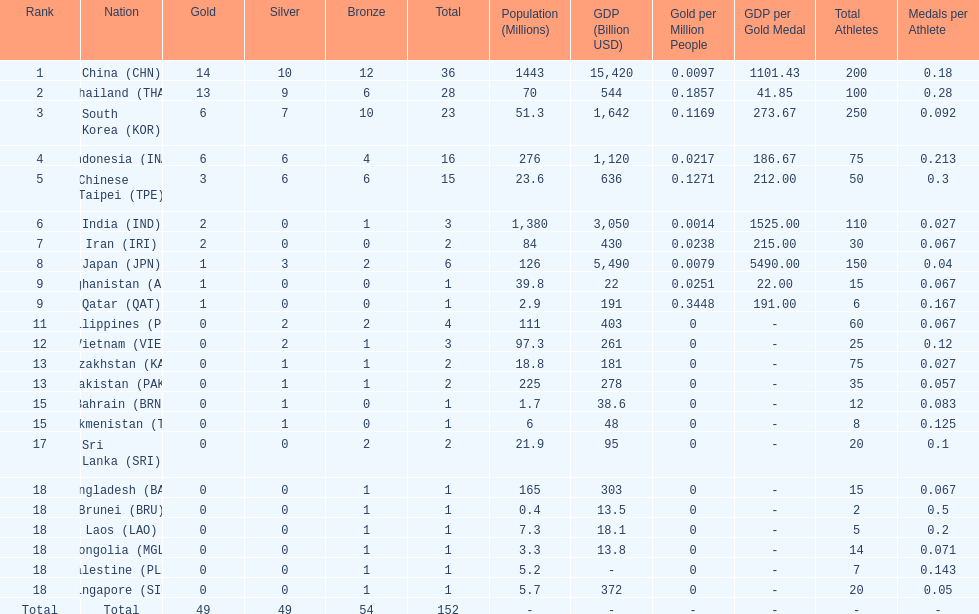How many total gold medal have been given? 49. Can you give me this table as a dict? {'header': ['Rank', 'Nation', 'Gold', 'Silver', 'Bronze', 'Total', 'Population (Millions)', 'GDP (Billion USD)', 'Gold per Million People', 'GDP per Gold Medal', 'Total Athletes', 'Medals per Athlete'], 'rows': [['1', 'China\xa0(CHN)', '14', '10', '12', '36', '1443', '15,420', '0.0097', '1101.43', '200', '0.18'], ['2', 'Thailand\xa0(THA)', '13', '9', '6', '28', '70', '544', '0.1857', '41.85', '100', '0.28'], ['3', 'South Korea\xa0(KOR)', '6', '7', '10', '23', '51.3', '1,642', '0.1169', '273.67', '250', '0.092'], ['4', 'Indonesia\xa0(INA)', '6', '6', '4', '16', '276', '1,120', '0.0217', '186.67', '75', '0.213'], ['5', 'Chinese Taipei\xa0(TPE)', '3', '6', '6', '15', '23.6', '636', '0.1271', '212.00', '50', '0.3'], ['6', 'India\xa0(IND)', '2', '0', '1', '3', '1,380', '3,050', '0.0014', '1525.00', '110', '0.027'], ['7', 'Iran\xa0(IRI)', '2', '0', '0', '2', '84', '430', '0.0238', '215.00', '30', '0.067'], ['8', 'Japan\xa0(JPN)', '1', '3', '2', '6', '126', '5,490', '0.0079', '5490.00', '150', '0.04'], ['9', 'Afghanistan\xa0(AFG)', '1', '0', '0', '1', '39.8', '22', '0.0251', '22.00', '15', '0.067'], ['9', 'Qatar\xa0(QAT)', '1', '0', '0', '1', '2.9', '191', '0.3448', '191.00', '6', '0.167'], ['11', 'Philippines\xa0(PHI)', '0', '2', '2', '4', '111', '403', '0', '-', '60', '0.067'], ['12', 'Vietnam\xa0(VIE)', '0', '2', '1', '3', '97.3', '261', '0', '-', '25', '0.12'], ['13', 'Kazakhstan\xa0(KAZ)', '0', '1', '1', '2', '18.8', '181', '0', '-', '75', '0.027'], ['13', 'Pakistan\xa0(PAK)', '0', '1', '1', '2', '225', '278', '0', '-', '35', '0.057'], ['15', 'Bahrain\xa0(BRN)', '0', '1', '0', '1', '1.7', '38.6', '0', '-', '12', '0.083'], ['15', 'Turkmenistan\xa0(TKM)', '0', '1', '0', '1', '6', '48', '0', '-', '8', '0.125'], ['17', 'Sri Lanka\xa0(SRI)', '0', '0', '2', '2', '21.9', '95', '0', '-', '20', '0.1'], ['18', 'Bangladesh\xa0(BAN)', '0', '0', '1', '1', '165', '303', '0', '-', '15', '0.067'], ['18', 'Brunei\xa0(BRU)', '0', '0', '1', '1', '0.4', '13.5', '0', '-', '2', '0.5'], ['18', 'Laos\xa0(LAO)', '0', '0', '1', '1', '7.3', '18.1', '0', '-', '5', '0.2'], ['18', 'Mongolia\xa0(MGL)', '0', '0', '1', '1', '3.3', '13.8', '0', '-', '14', '0.071'], ['18', 'Palestine\xa0(PLE)', '0', '0', '1', '1', '5.2', '-', '0', '-', '7', '0.143'], ['18', 'Singapore\xa0(SIN)', '0', '0', '1', '1', '5.7', '372', '0', '-', '20', '0.05'], ['Total', 'Total', '49', '49', '54', '152', '-', '-', '-', '-', '-', '-']]} 